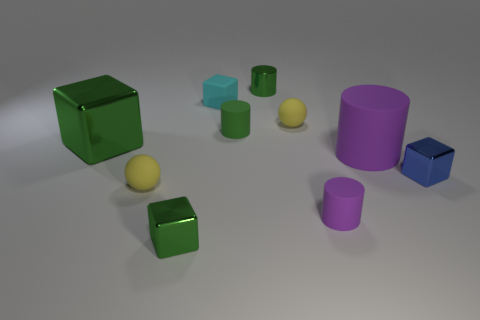What is the size of the purple matte cylinder behind the tiny shiny cube that is behind the small green block?
Offer a very short reply. Large. Do the big cube and the tiny metal cylinder have the same color?
Your answer should be compact. Yes. How many shiny objects are tiny cyan blocks or large cylinders?
Your answer should be compact. 0. How many big cylinders are there?
Offer a terse response. 1. Do the small cylinder behind the cyan matte cube and the yellow ball in front of the blue thing have the same material?
Your answer should be very brief. No. There is a small metallic thing that is the same shape as the large purple matte object; what color is it?
Your answer should be very brief. Green. There is a small thing that is to the right of the purple rubber cylinder that is behind the tiny purple rubber cylinder; what is its material?
Provide a succinct answer. Metal. There is a tiny yellow object in front of the tiny green rubber cylinder; is its shape the same as the tiny yellow thing on the right side of the small metallic cylinder?
Provide a succinct answer. Yes. What is the size of the rubber cylinder that is behind the blue shiny cube and right of the tiny green rubber cylinder?
Offer a very short reply. Large. How many other objects are there of the same color as the big cylinder?
Your response must be concise. 1. 